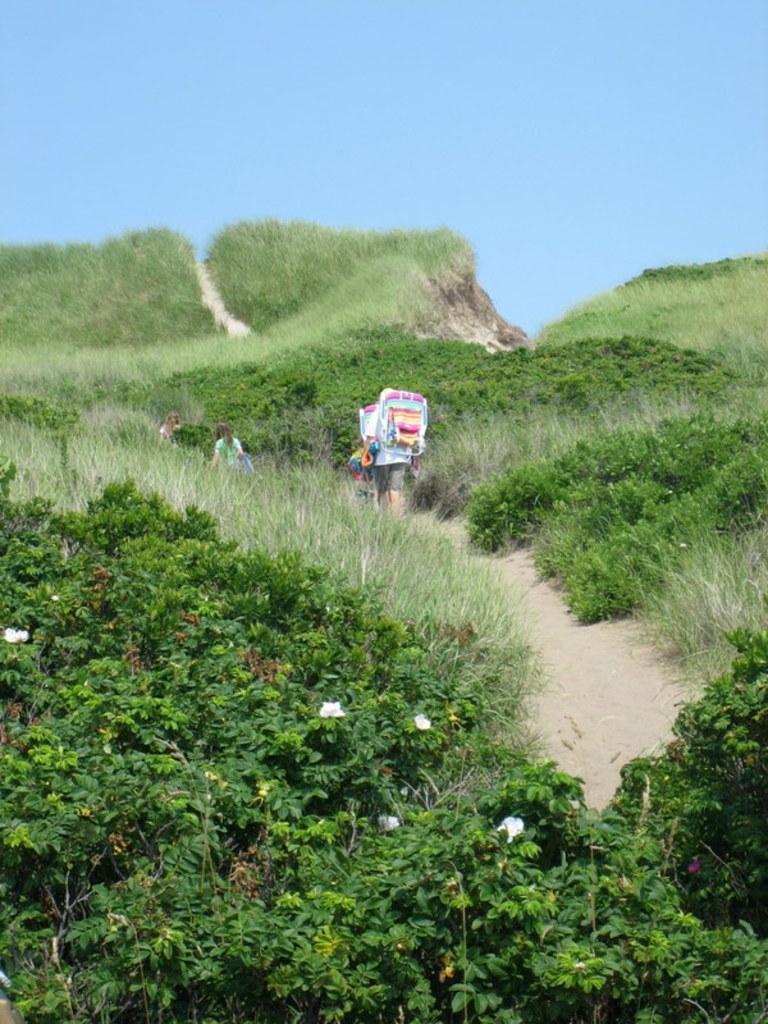Can you describe this image briefly? In this picture I can observe some plants and grass on the ground. There is a path in which some people are walking. In the background there is sky. 